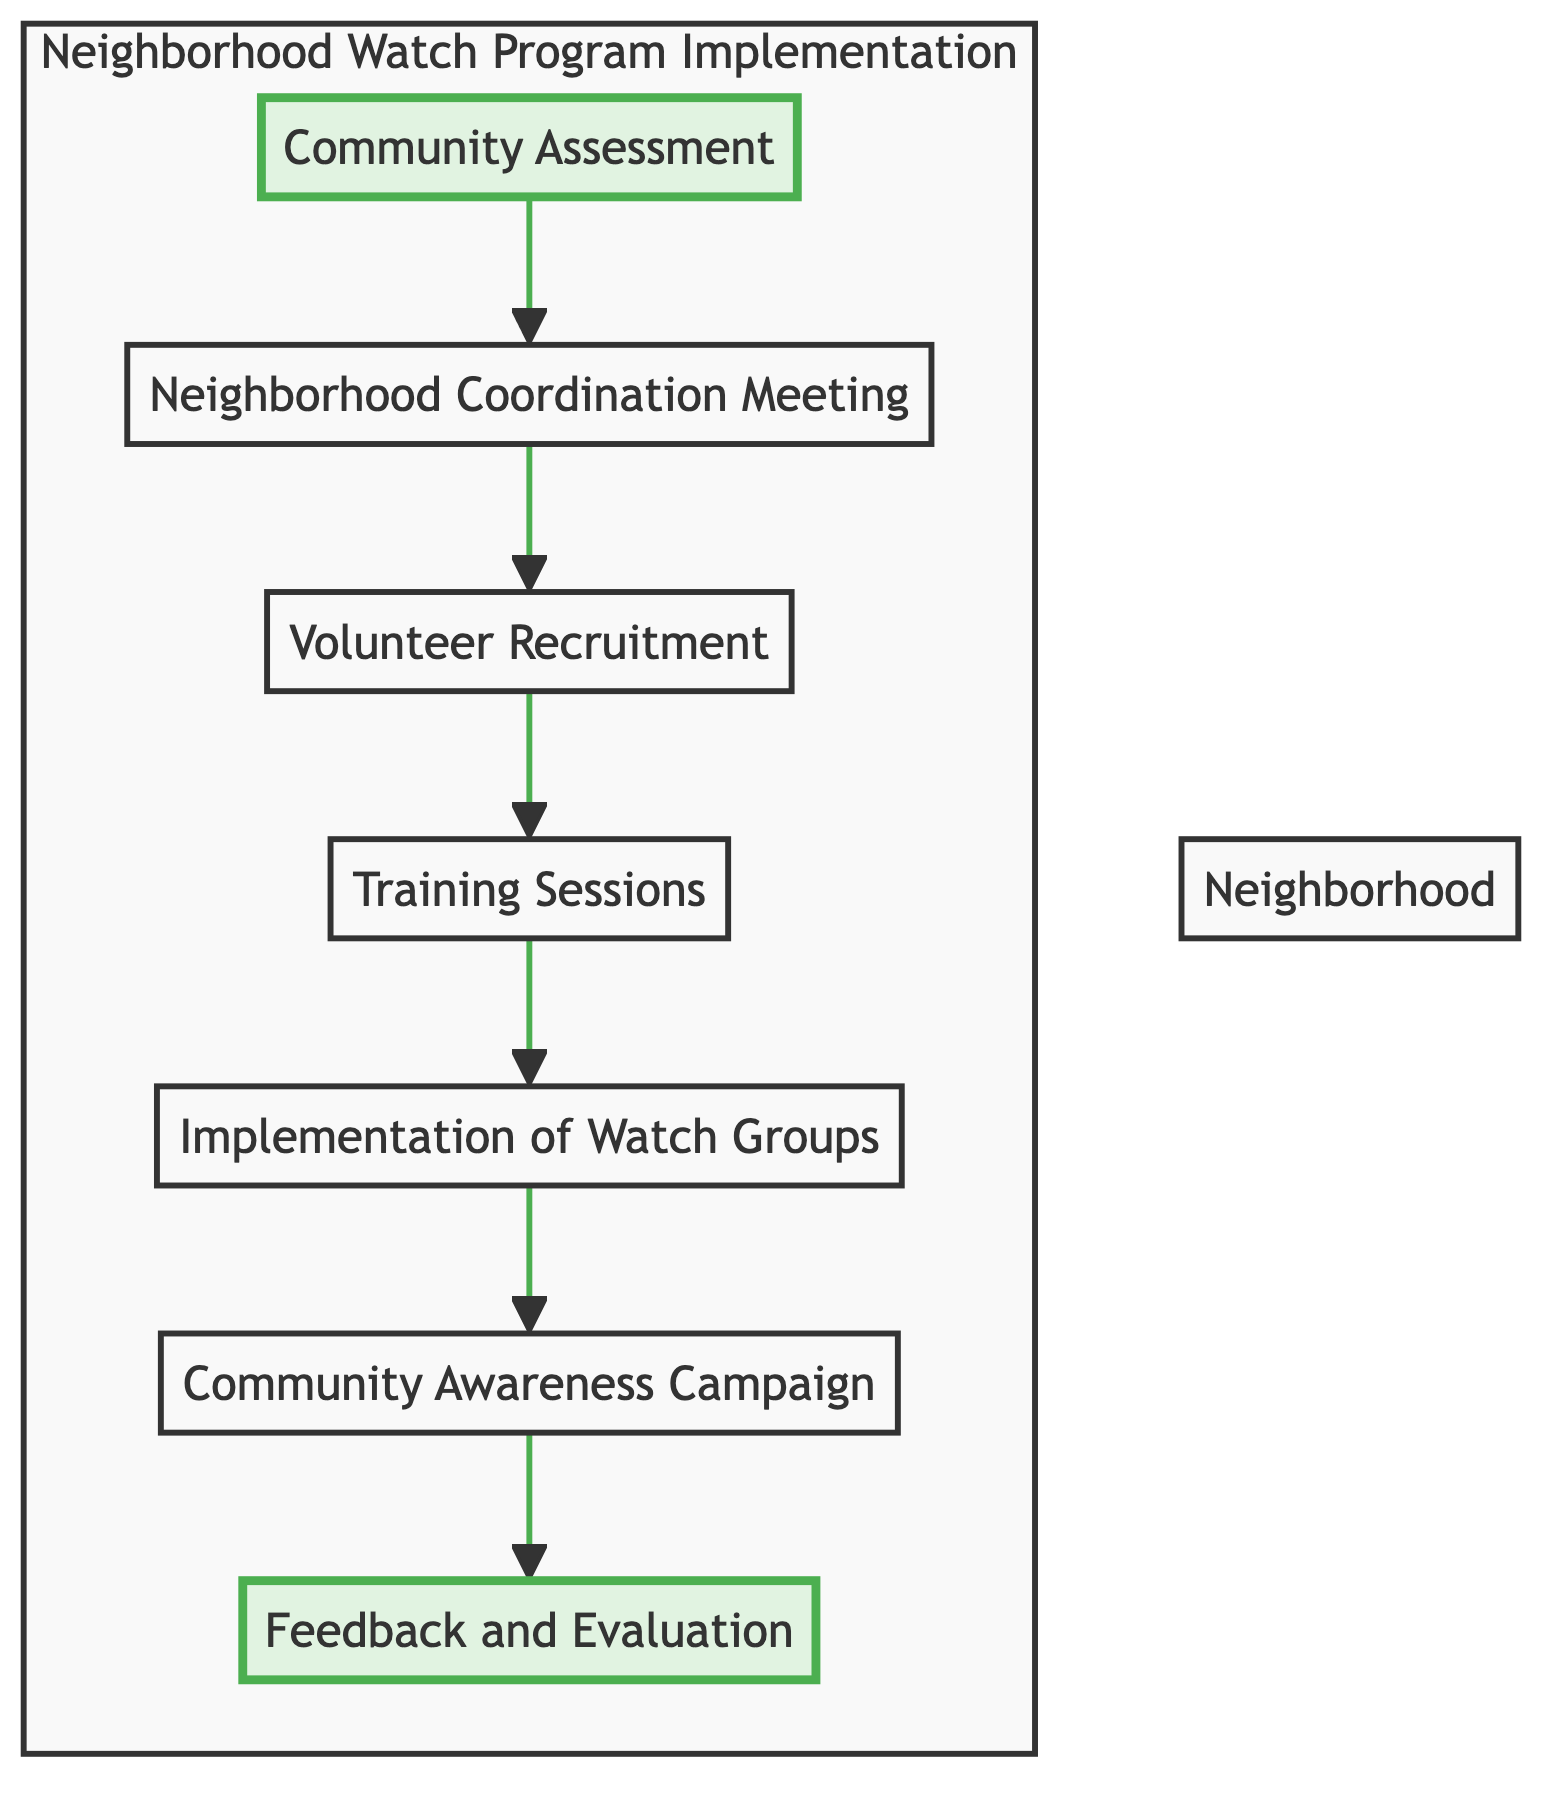What is the first step in the Neighborhood Watch program implementation? The first step, as shown in the diagram, is "Community Assessment". This is indicated by the first node in the flowchart.
Answer: Community Assessment How many nodes are present in the diagram? The diagram contains a total of seven nodes, which represent different steps in the Neighborhood Watch program implementation process.
Answer: 7 What follows the "Neighborhood Coordination Meeting"? The node that follows "Neighborhood Coordination Meeting" is "Volunteer Recruitment", as indicated by the directional arrow leading from the second node to the third node.
Answer: Volunteer Recruitment What is the last step in the process? The last step is "Feedback and Evaluation", which is shown as the final node in the flowchart and is highlighted to indicate its significance in the ongoing improvement of the program.
Answer: Feedback and Evaluation Which step is associated with training for volunteers? The step associated with training for volunteers is "Training Sessions". It is the fourth node in the flowchart, clearly labeled as part of the implementation process.
Answer: Training Sessions What is the purpose of the "Community Awareness Campaign"? The purpose of the "Community Awareness Campaign" is to promote the Neighborhood Watch program to engage more residents and increase awareness, as described in the node's text.
Answer: Increase awareness How many edges connect the nodes in the diagram? There are six edges connecting the nodes in the diagram since there are seven nodes, and each node (except the last one) connects to the next one in the implementation flow.
Answer: 6 In which order do the training sessions and watch groups occur? "Training Sessions" occur before "Implementation of Watch Groups." It follows the sequence from the fourth node to the fifth node, indicating that training precedes establishing the groups.
Answer: Training before Watch Groups What does the highlighted nodes signify in the flowchart? The highlighted nodes signify key aspects of the process that are crucial to the implementation of the Neighborhood Watch program. Specifically, these are the first and last steps, emphasizing their importance.
Answer: Key aspects of the process 